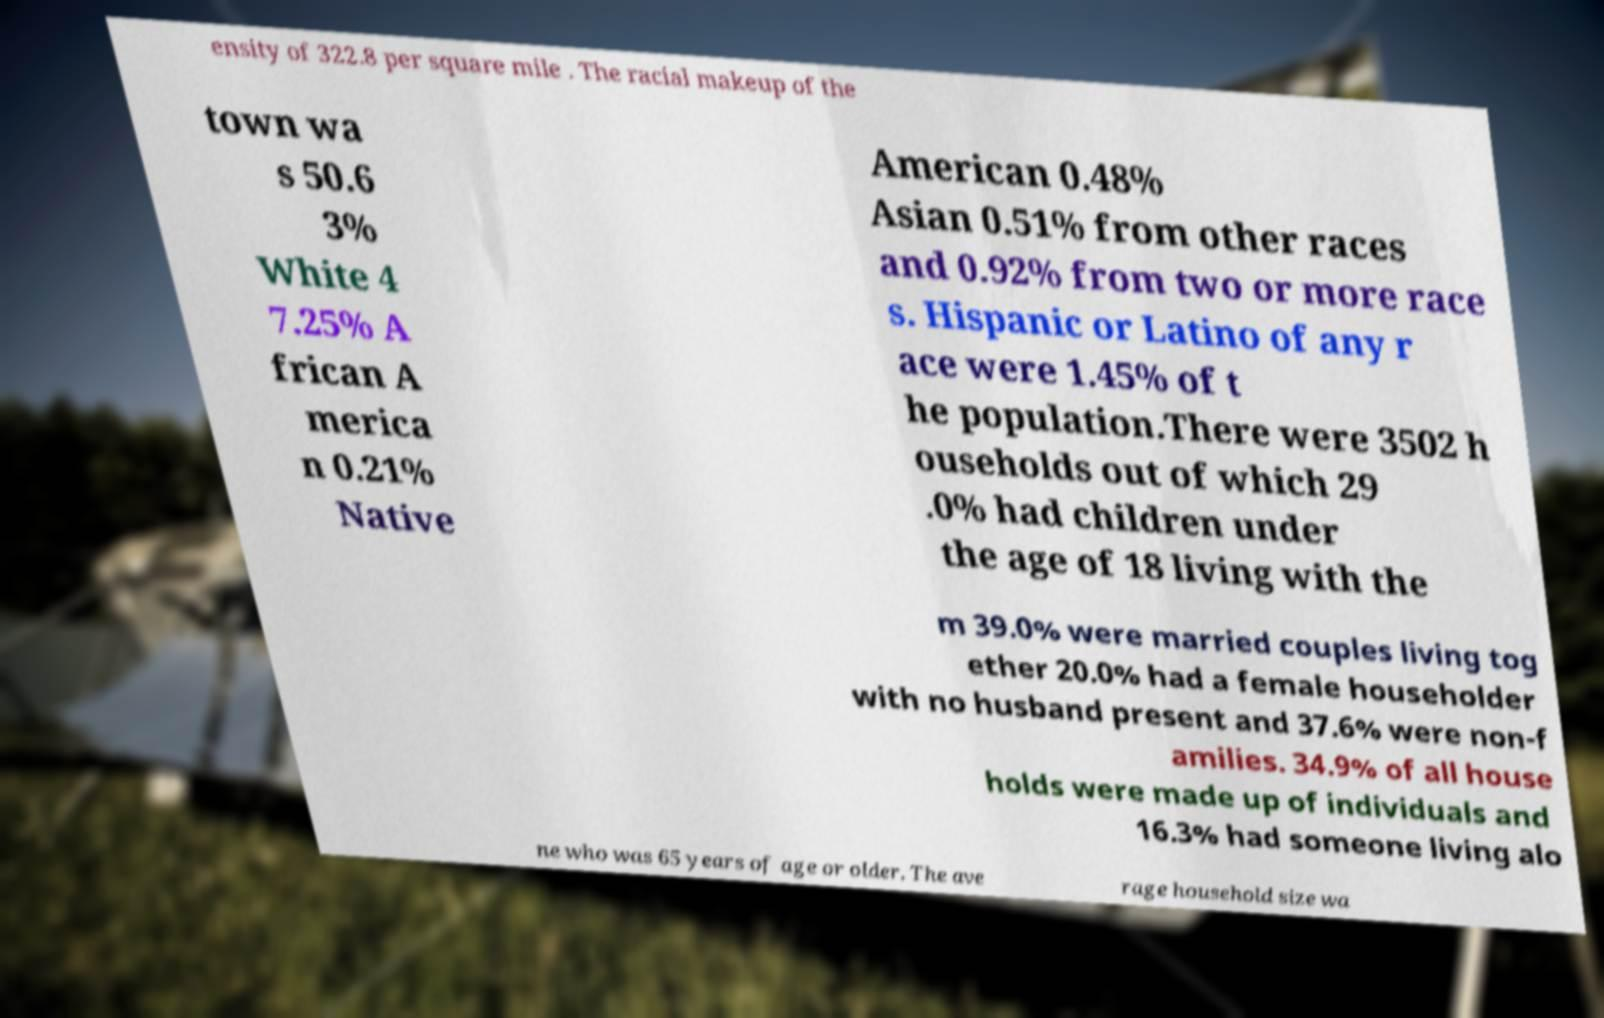I need the written content from this picture converted into text. Can you do that? ensity of 322.8 per square mile . The racial makeup of the town wa s 50.6 3% White 4 7.25% A frican A merica n 0.21% Native American 0.48% Asian 0.51% from other races and 0.92% from two or more race s. Hispanic or Latino of any r ace were 1.45% of t he population.There were 3502 h ouseholds out of which 29 .0% had children under the age of 18 living with the m 39.0% were married couples living tog ether 20.0% had a female householder with no husband present and 37.6% were non-f amilies. 34.9% of all house holds were made up of individuals and 16.3% had someone living alo ne who was 65 years of age or older. The ave rage household size wa 